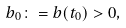Convert formula to latex. <formula><loc_0><loc_0><loc_500><loc_500>b _ { 0 } \colon = b ( t _ { 0 } ) > 0 ,</formula> 